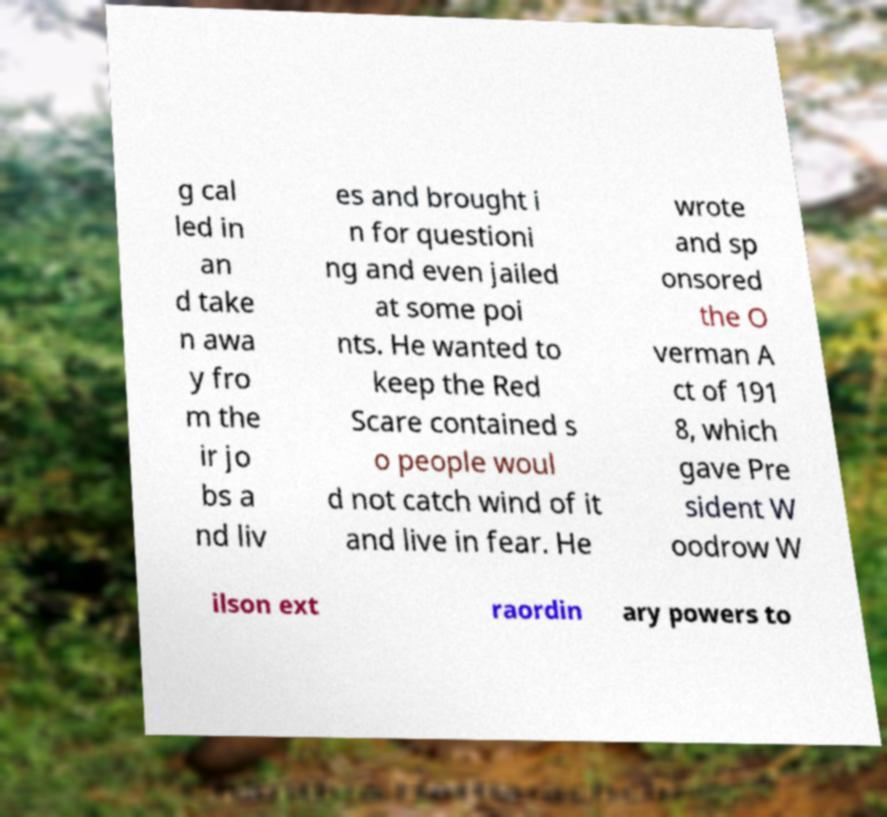Can you read and provide the text displayed in the image?This photo seems to have some interesting text. Can you extract and type it out for me? g cal led in an d take n awa y fro m the ir jo bs a nd liv es and brought i n for questioni ng and even jailed at some poi nts. He wanted to keep the Red Scare contained s o people woul d not catch wind of it and live in fear. He wrote and sp onsored the O verman A ct of 191 8, which gave Pre sident W oodrow W ilson ext raordin ary powers to 